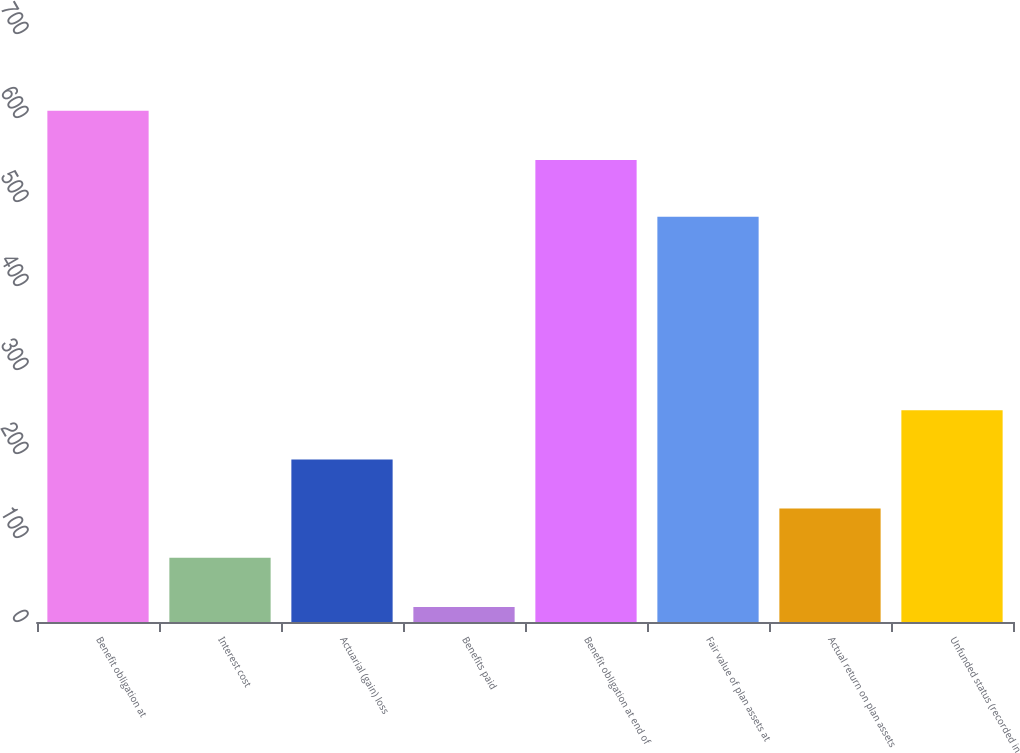Convert chart to OTSL. <chart><loc_0><loc_0><loc_500><loc_500><bar_chart><fcel>Benefit obligation at<fcel>Interest cost<fcel>Actuarial (gain) loss<fcel>Benefits paid<fcel>Benefit obligation at end of<fcel>Fair value of plan assets at<fcel>Actual return on plan assets<fcel>Unfunded status (recorded in<nl><fcel>608.5<fcel>76.5<fcel>193.5<fcel>18<fcel>550<fcel>482.5<fcel>135<fcel>252<nl></chart> 